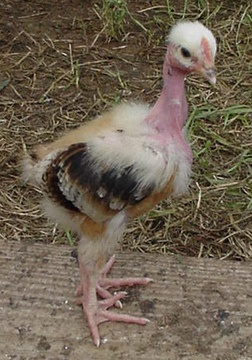Describe the objects in this image and their specific colors. I can see a bird in black, darkgray, and gray tones in this image. 